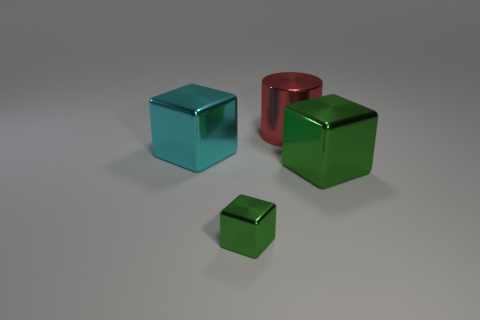What shape is the other thing that is the same color as the tiny object?
Your answer should be compact. Cube. There is a cube in front of the large green object; is its color the same as the big metallic block right of the large cyan shiny cube?
Your response must be concise. Yes. What number of other metal cubes are the same color as the small block?
Make the answer very short. 1. There is a big object that is behind the big block left of the small green thing; what shape is it?
Provide a succinct answer. Cylinder. Do the cylinder and the green metallic cube that is left of the red object have the same size?
Your answer should be compact. No. There is a cube that is behind the big shiny cube to the right of the metallic block behind the large green block; what is its size?
Your response must be concise. Large. How many objects are big blocks on the right side of the large red cylinder or big red metallic things?
Your answer should be compact. 2. How many cylinders are behind the green cube that is to the right of the metallic cylinder?
Provide a succinct answer. 1. Is the number of metal cylinders that are to the right of the big cyan cube greater than the number of purple matte things?
Ensure brevity in your answer.  Yes. There is a block that is both behind the tiny metallic object and right of the cyan metallic block; what size is it?
Provide a short and direct response. Large. 